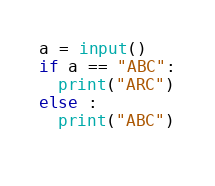<code> <loc_0><loc_0><loc_500><loc_500><_Python_>a = input()
if a == "ABC":
  print("ARC")
else :
  print("ABC")
  </code> 